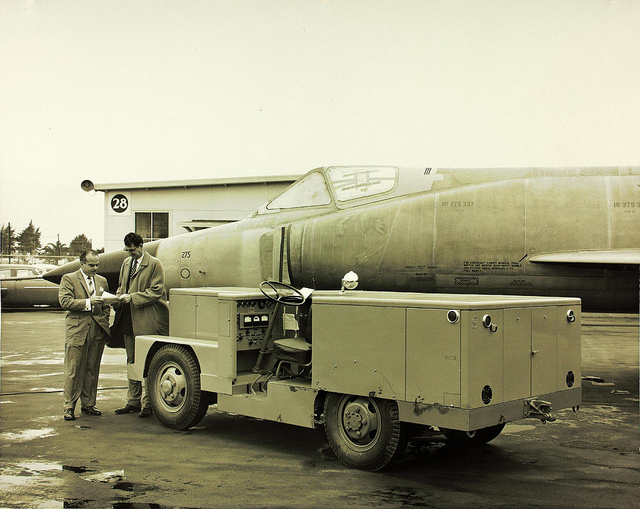Please extract the text content from this image. 28 